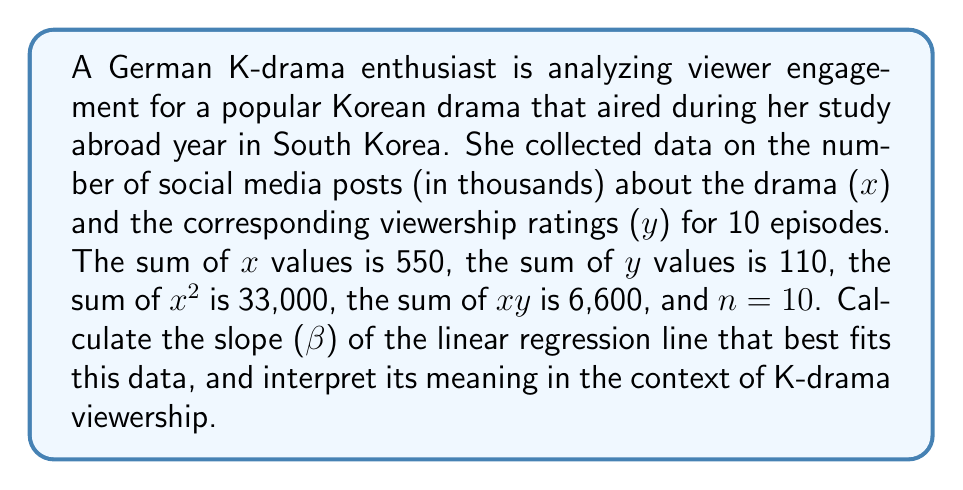Can you answer this question? To find the slope (β) of the linear regression line, we'll use the formula:

$$ \beta = \frac{n\sum xy - \sum x \sum y}{n\sum x^2 - (\sum x)^2} $$

Given:
- $\sum x = 550$
- $\sum y = 110$
- $\sum x^2 = 33,000$
- $\sum xy = 6,600$
- $n = 10$

Let's substitute these values into the formula:

$$ \beta = \frac{10(6,600) - (550)(110)}{10(33,000) - (550)^2} $$

$$ \beta = \frac{66,000 - 60,500}{330,000 - 302,500} $$

$$ \beta = \frac{5,500}{27,500} $$

$$ \beta = 0.2 $$

Interpretation: The slope (β) of 0.2 indicates that for every 1,000 increase in social media posts about the K-drama, the viewership rating tends to increase by 0.2 points on average. This positive relationship suggests that higher social media engagement is associated with higher viewership ratings for this Korean drama.
Answer: $\beta = 0.2$ 